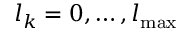<formula> <loc_0><loc_0><loc_500><loc_500>l _ { k } = 0 , \dots , l _ { \max }</formula> 